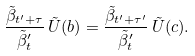<formula> <loc_0><loc_0><loc_500><loc_500>\frac { \tilde { \beta } _ { t ^ { \prime } + \tau } } { \tilde { \beta } _ { t } ^ { \prime } } \, \tilde { U } ( b ) = \frac { \tilde { \beta } _ { t ^ { \prime } + \tau ^ { \prime } } } { \tilde { \beta } _ { t } ^ { \prime } } \, \tilde { U } ( c ) .</formula> 